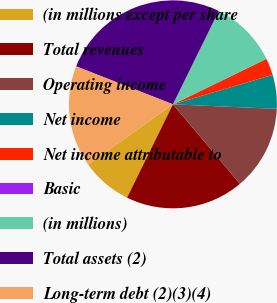Convert chart to OTSL. <chart><loc_0><loc_0><loc_500><loc_500><pie_chart><fcel>(in millions except per share<fcel>Total revenues<fcel>Operating income<fcel>Net income<fcel>Net income attributable to<fcel>Basic<fcel>(in millions)<fcel>Total assets (2)<fcel>Long-term debt (2)(3)(4)<nl><fcel>7.9%<fcel>18.42%<fcel>13.16%<fcel>5.27%<fcel>2.63%<fcel>0.0%<fcel>10.53%<fcel>26.31%<fcel>15.79%<nl></chart> 